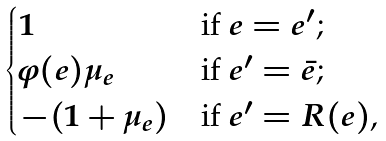Convert formula to latex. <formula><loc_0><loc_0><loc_500><loc_500>\begin{cases} 1 & \text {if $e=e^{\prime}$;} \\ \varphi ( e ) \mu _ { e } & \text {if $e^{\prime}=\bar{e}$;} \\ - ( 1 + \mu _ { e } ) & \text {if $e^{\prime}=R(e)$,} \end{cases}</formula> 